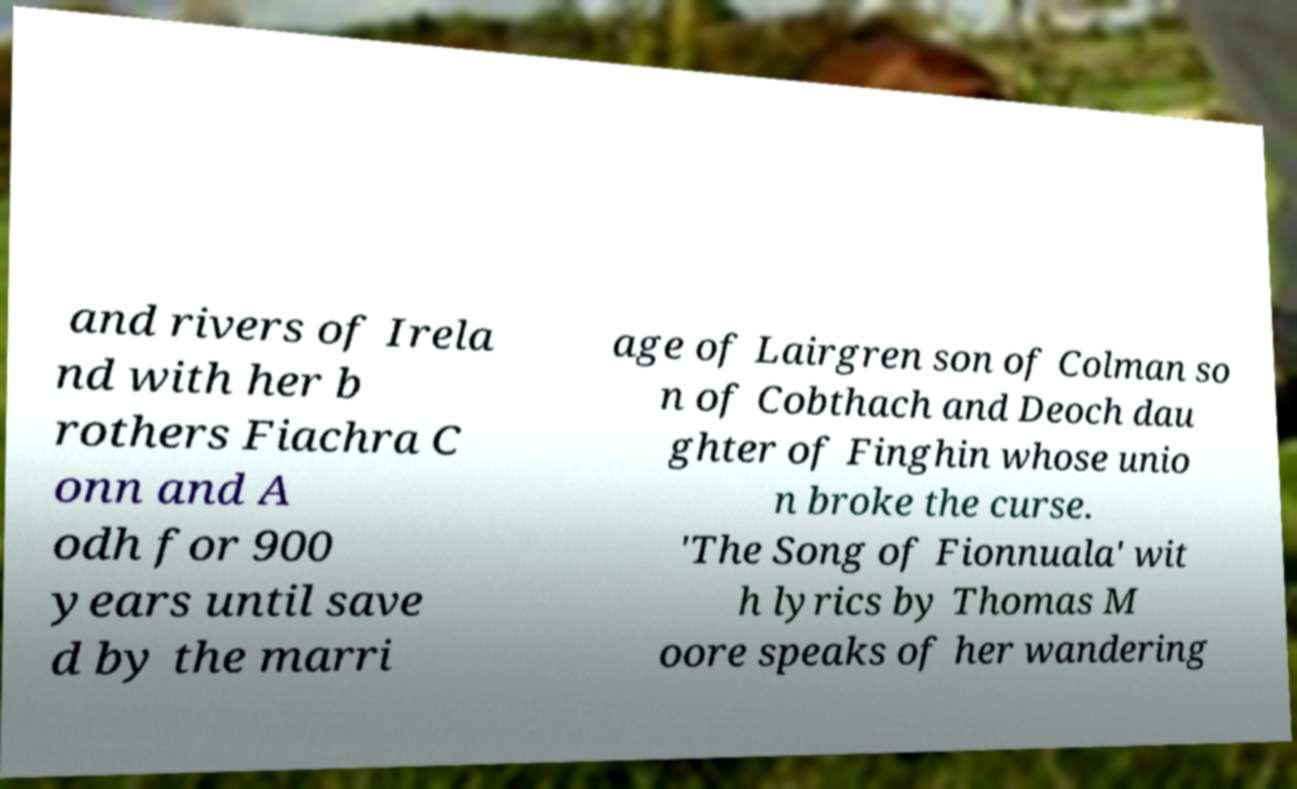Can you read and provide the text displayed in the image?This photo seems to have some interesting text. Can you extract and type it out for me? and rivers of Irela nd with her b rothers Fiachra C onn and A odh for 900 years until save d by the marri age of Lairgren son of Colman so n of Cobthach and Deoch dau ghter of Finghin whose unio n broke the curse. 'The Song of Fionnuala' wit h lyrics by Thomas M oore speaks of her wandering 